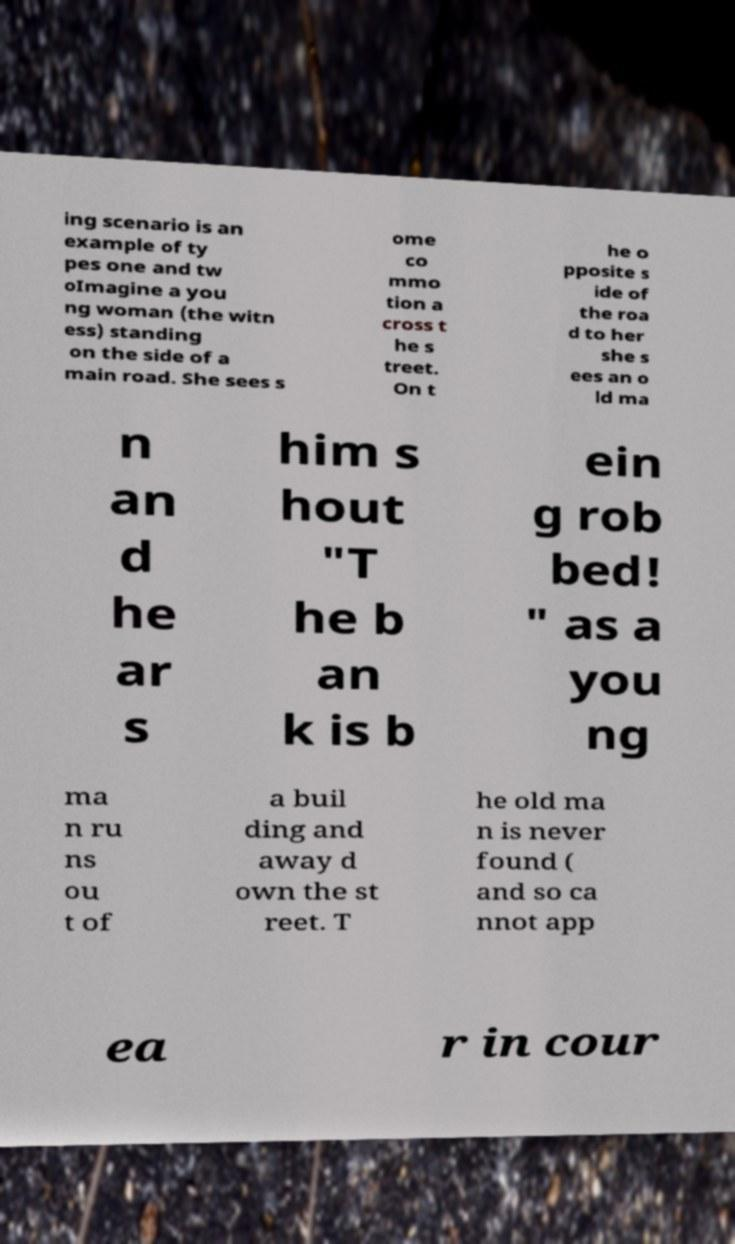Please read and relay the text visible in this image. What does it say? ing scenario is an example of ty pes one and tw oImagine a you ng woman (the witn ess) standing on the side of a main road. She sees s ome co mmo tion a cross t he s treet. On t he o pposite s ide of the roa d to her she s ees an o ld ma n an d he ar s him s hout "T he b an k is b ein g rob bed! " as a you ng ma n ru ns ou t of a buil ding and away d own the st reet. T he old ma n is never found ( and so ca nnot app ea r in cour 